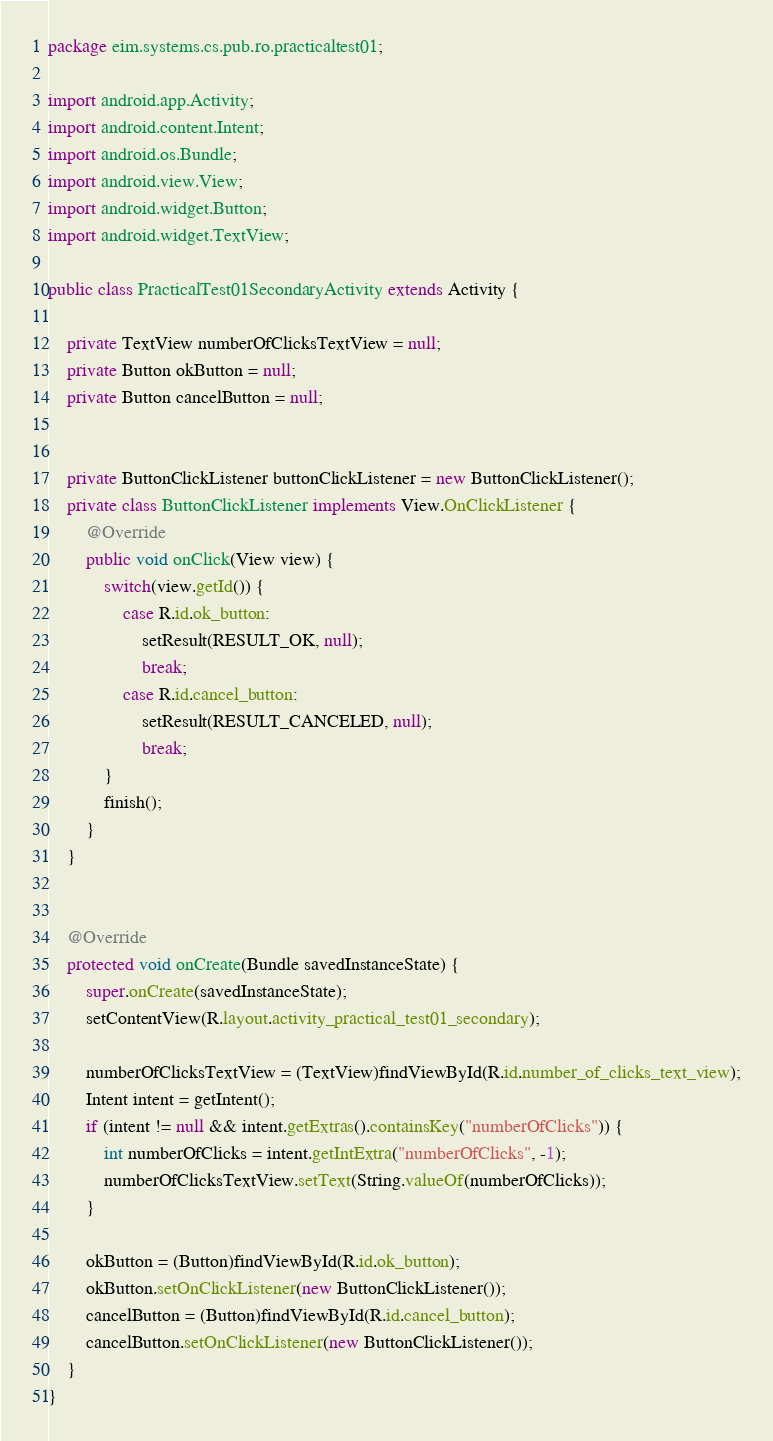Convert code to text. <code><loc_0><loc_0><loc_500><loc_500><_Java_>package eim.systems.cs.pub.ro.practicaltest01;

import android.app.Activity;
import android.content.Intent;
import android.os.Bundle;
import android.view.View;
import android.widget.Button;
import android.widget.TextView;

public class PracticalTest01SecondaryActivity extends Activity {

    private TextView numberOfClicksTextView = null;
    private Button okButton = null;
    private Button cancelButton = null;


    private ButtonClickListener buttonClickListener = new ButtonClickListener();
    private class ButtonClickListener implements View.OnClickListener {
        @Override
        public void onClick(View view) {
            switch(view.getId()) {
                case R.id.ok_button:
                    setResult(RESULT_OK, null);
                    break;
                case R.id.cancel_button:
                    setResult(RESULT_CANCELED, null);
                    break;
            }
            finish();
        }
    }


    @Override
    protected void onCreate(Bundle savedInstanceState) {
        super.onCreate(savedInstanceState);
        setContentView(R.layout.activity_practical_test01_secondary);

        numberOfClicksTextView = (TextView)findViewById(R.id.number_of_clicks_text_view);
        Intent intent = getIntent();
        if (intent != null && intent.getExtras().containsKey("numberOfClicks")) {
            int numberOfClicks = intent.getIntExtra("numberOfClicks", -1);
            numberOfClicksTextView.setText(String.valueOf(numberOfClicks));
        }

        okButton = (Button)findViewById(R.id.ok_button);
        okButton.setOnClickListener(new ButtonClickListener());
        cancelButton = (Button)findViewById(R.id.cancel_button);
        cancelButton.setOnClickListener(new ButtonClickListener());
    }
}
</code> 